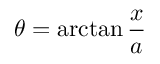Convert formula to latex. <formula><loc_0><loc_0><loc_500><loc_500>\theta = \arctan { \frac { x } { a } }</formula> 